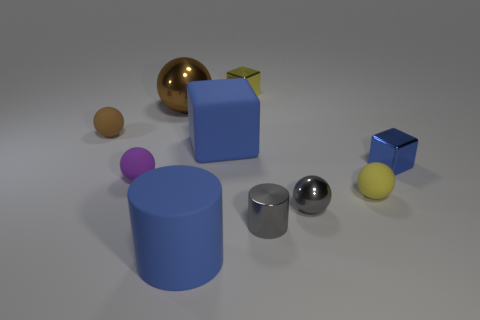What is the color of the tiny cylinder that is made of the same material as the large brown sphere?
Give a very brief answer. Gray. How many objects are either metallic objects to the left of the tiny blue shiny thing or big brown things?
Your response must be concise. 4. What is the size of the cylinder left of the yellow metal cube?
Ensure brevity in your answer.  Large. There is a brown metal ball; is its size the same as the blue block that is to the right of the small yellow metallic cube?
Offer a terse response. No. There is a tiny block to the right of the tiny metal block that is to the left of the yellow rubber object; what color is it?
Offer a terse response. Blue. What number of other things are there of the same color as the tiny metal ball?
Provide a succinct answer. 1. The purple object is what size?
Provide a succinct answer. Small. Is the number of blocks that are in front of the yellow metallic object greater than the number of spheres that are to the left of the big brown thing?
Make the answer very short. No. What number of shiny objects are to the left of the big blue rubber object that is behind the purple rubber thing?
Keep it short and to the point. 1. There is a matte object right of the small yellow metallic cube; is it the same shape as the blue shiny thing?
Ensure brevity in your answer.  No. 